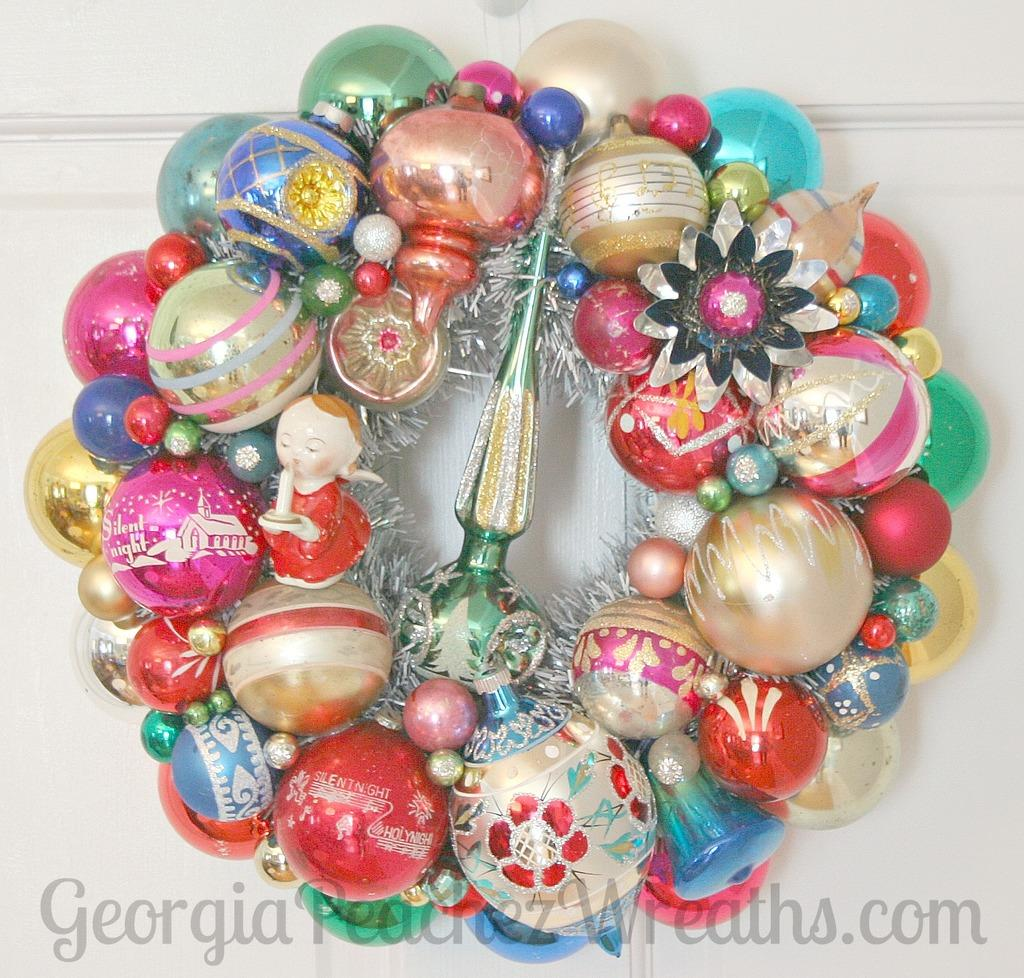What types of objects can be seen in the image? There are decorative objects and a toy in the image. Where are these objects placed? The objects are placed on a white surface. Is there any text visible in the image? Yes, there is text visible at the bottom of the image. What type of rhythm can be heard coming from the vest in the image? There is no vest present in the image, and therefore no rhythm can be heard. 